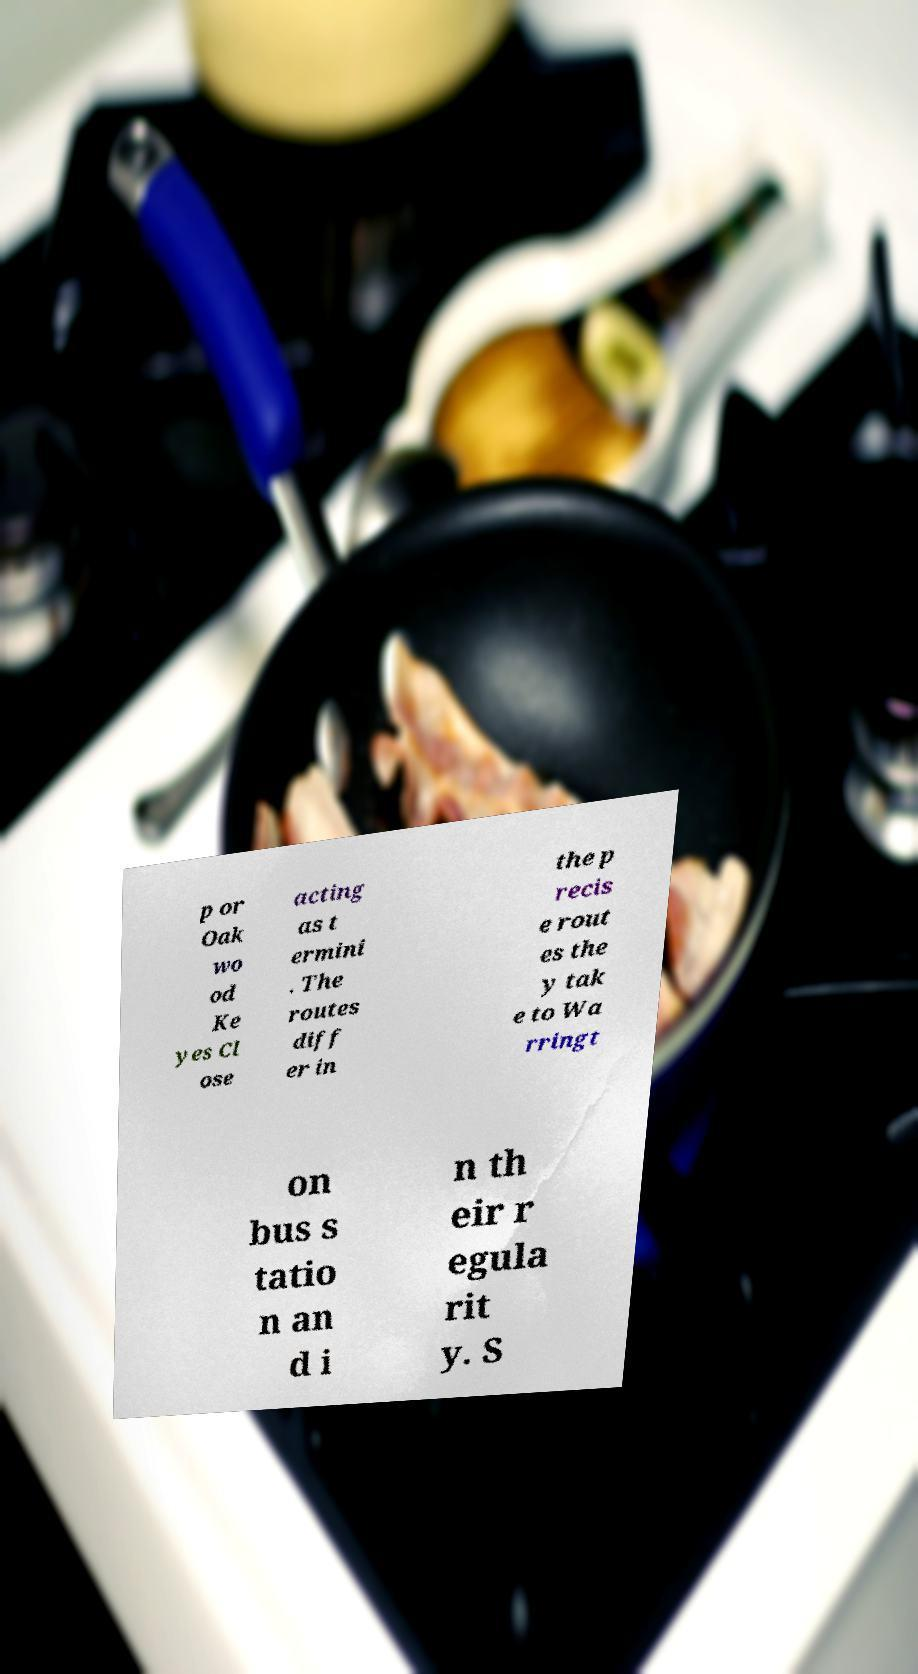What messages or text are displayed in this image? I need them in a readable, typed format. p or Oak wo od Ke yes Cl ose acting as t ermini . The routes diff er in the p recis e rout es the y tak e to Wa rringt on bus s tatio n an d i n th eir r egula rit y. S 